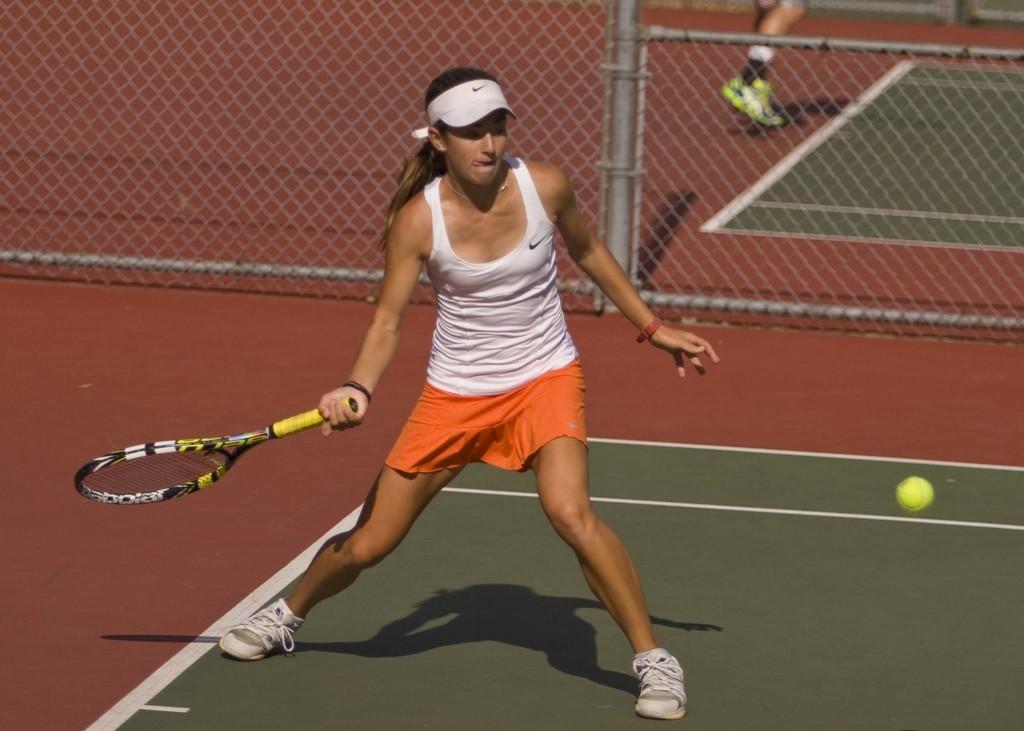How would you summarize this image in a sentence or two? In this image there is a woman holding a tennis bat, in front of her there is a ball in the air, behind her there is a fence, behind the fence we can see the legs of another person. 